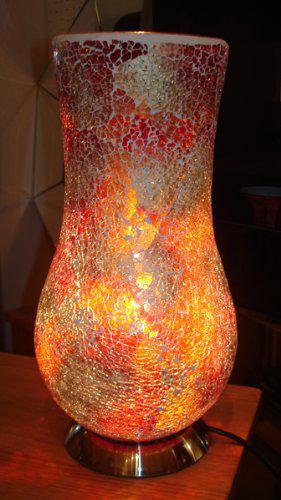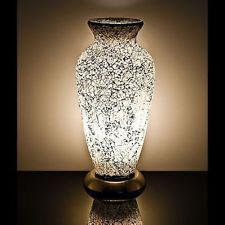The first image is the image on the left, the second image is the image on the right. Examine the images to the left and right. Is the description "there is a lamp shaped like an egg with the light reflecting on the wall and shiny surface it is sitting on, the base of the lamp is black and has a white line towards the top" accurate? Answer yes or no. No. 